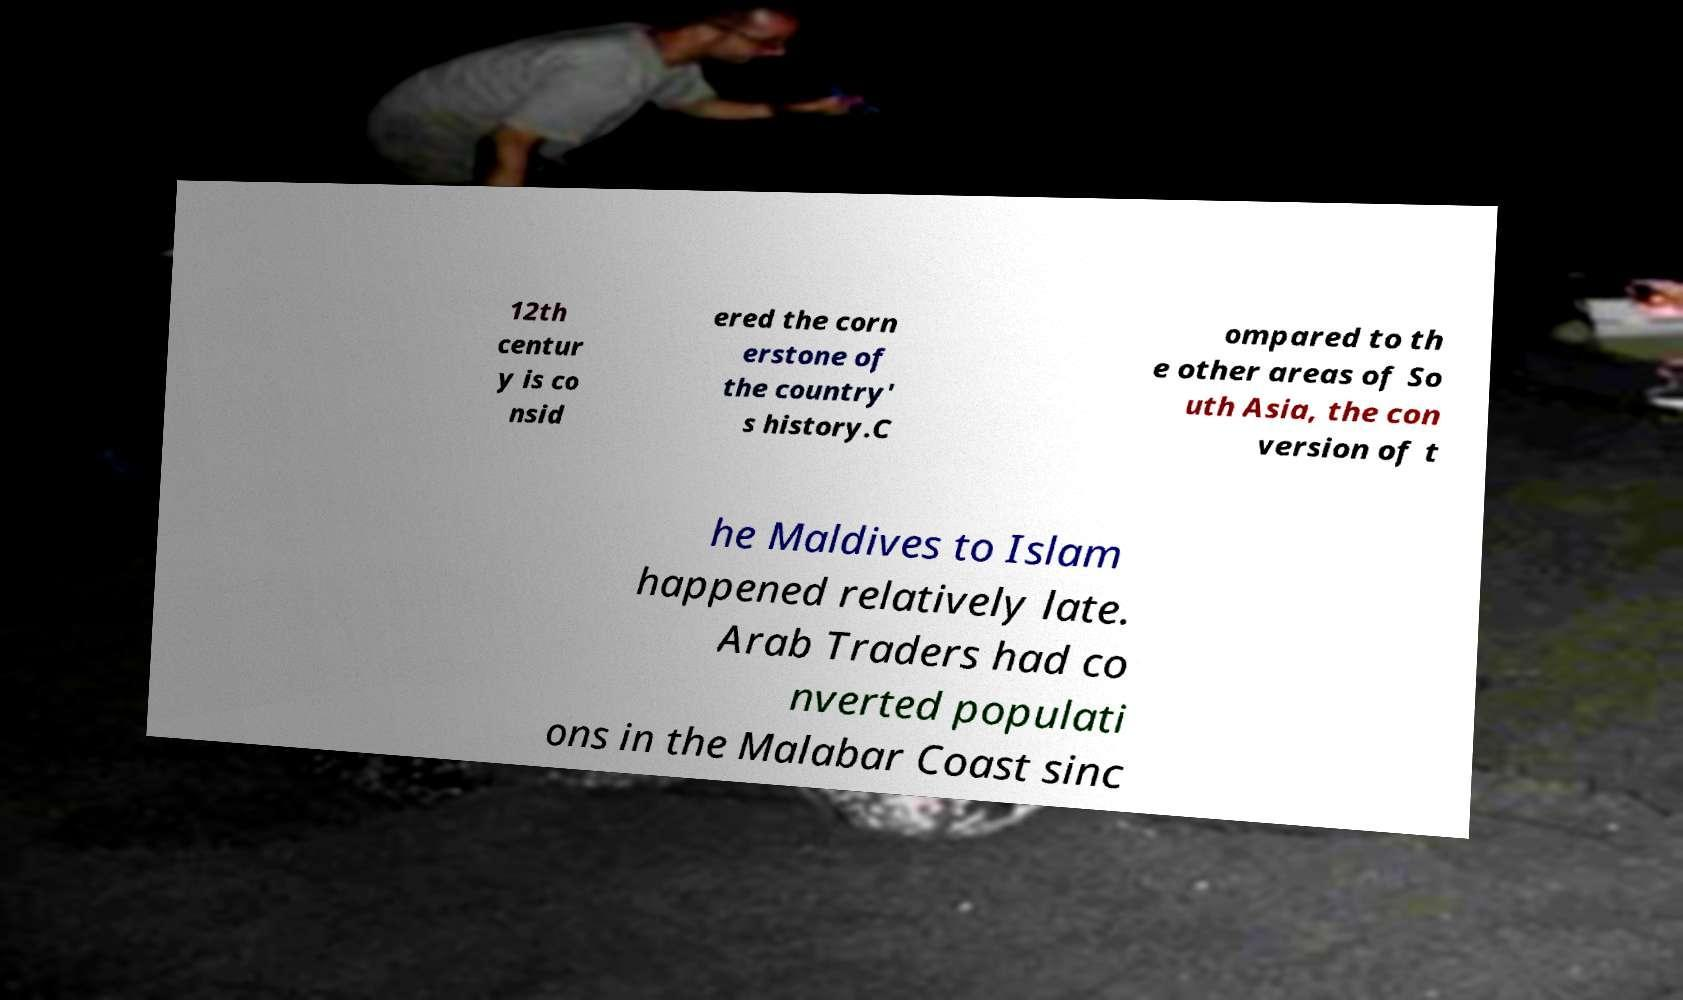Please read and relay the text visible in this image. What does it say? 12th centur y is co nsid ered the corn erstone of the country' s history.C ompared to th e other areas of So uth Asia, the con version of t he Maldives to Islam happened relatively late. Arab Traders had co nverted populati ons in the Malabar Coast sinc 